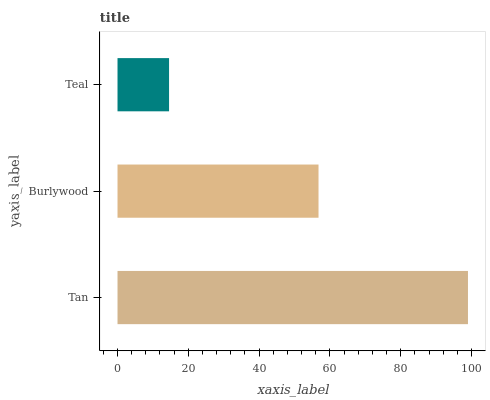Is Teal the minimum?
Answer yes or no. Yes. Is Tan the maximum?
Answer yes or no. Yes. Is Burlywood the minimum?
Answer yes or no. No. Is Burlywood the maximum?
Answer yes or no. No. Is Tan greater than Burlywood?
Answer yes or no. Yes. Is Burlywood less than Tan?
Answer yes or no. Yes. Is Burlywood greater than Tan?
Answer yes or no. No. Is Tan less than Burlywood?
Answer yes or no. No. Is Burlywood the high median?
Answer yes or no. Yes. Is Burlywood the low median?
Answer yes or no. Yes. Is Tan the high median?
Answer yes or no. No. Is Teal the low median?
Answer yes or no. No. 